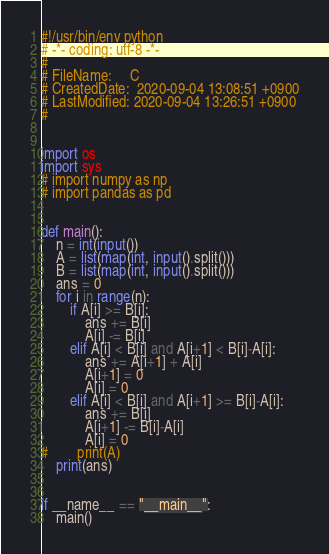<code> <loc_0><loc_0><loc_500><loc_500><_Python_>#!/usr/bin/env python
# -*- coding: utf-8 -*-
#
# FileName: 	C
# CreatedDate:  2020-09-04 13:08:51 +0900
# LastModified: 2020-09-04 13:26:51 +0900
#


import os
import sys
# import numpy as np
# import pandas as pd


def main():
    n = int(input())
    A = list(map(int, input().split()))
    B = list(map(int, input().split()))
    ans = 0
    for i in range(n):
        if A[i] >= B[i]:
            ans += B[i]
            A[i] -= B[i]
        elif A[i] < B[i] and A[i+1] < B[i]-A[i]:
            ans += A[i+1] + A[i]
            A[i+1] = 0
            A[i] = 0
        elif A[i] < B[i] and A[i+1] >= B[i]-A[i]:
            ans += B[i]
            A[i+1] -= B[i]-A[i]
            A[i] = 0
#        print(A)
    print(ans)


if __name__ == "__main__":
    main()
</code> 